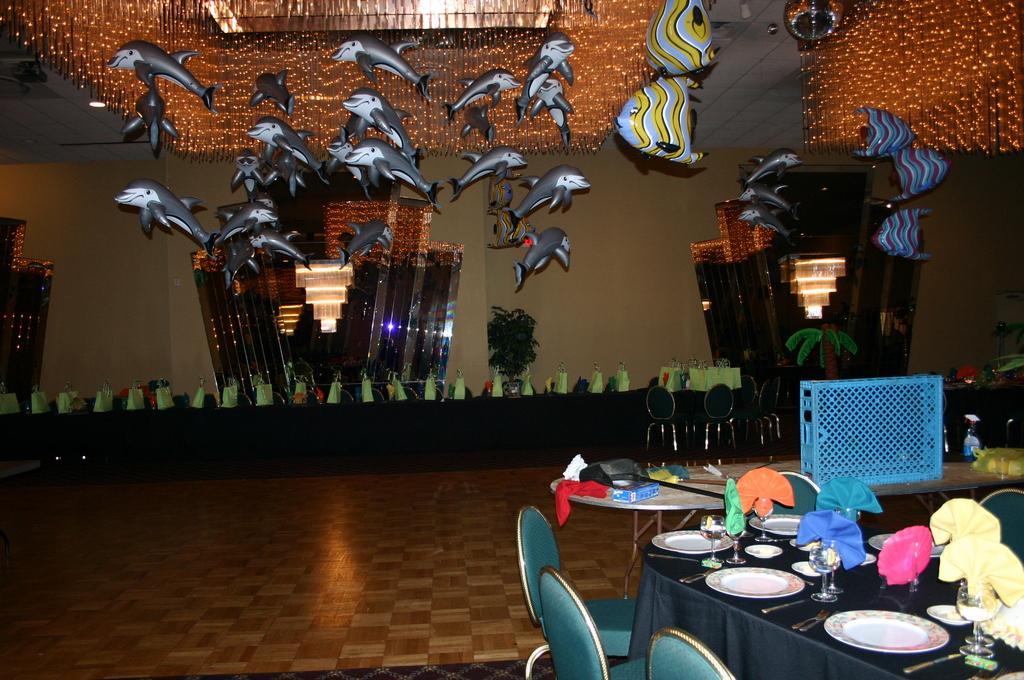Can you describe this image briefly? In the image on the right side,we can see chairs and tables. On the tables,we can see plates,glasses,clothes,boxes,tissue paper,spray bottle,basket and few other objects. In the background there is a wall,roof,string lights,tables,green color objects and few other objects. 